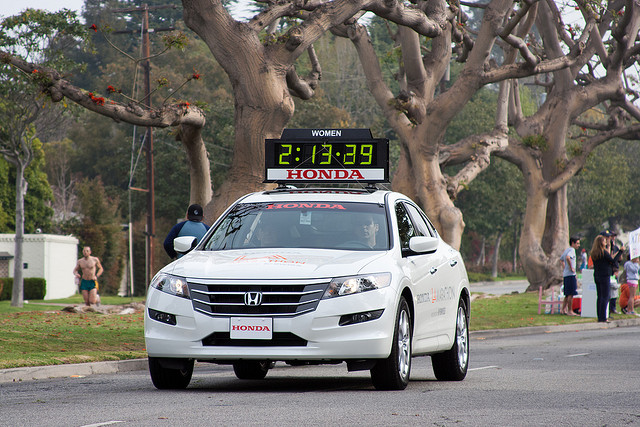Identify and read out the text in this image. 2:13-29 WOMEN HONDA HONDA HONDA 3321 